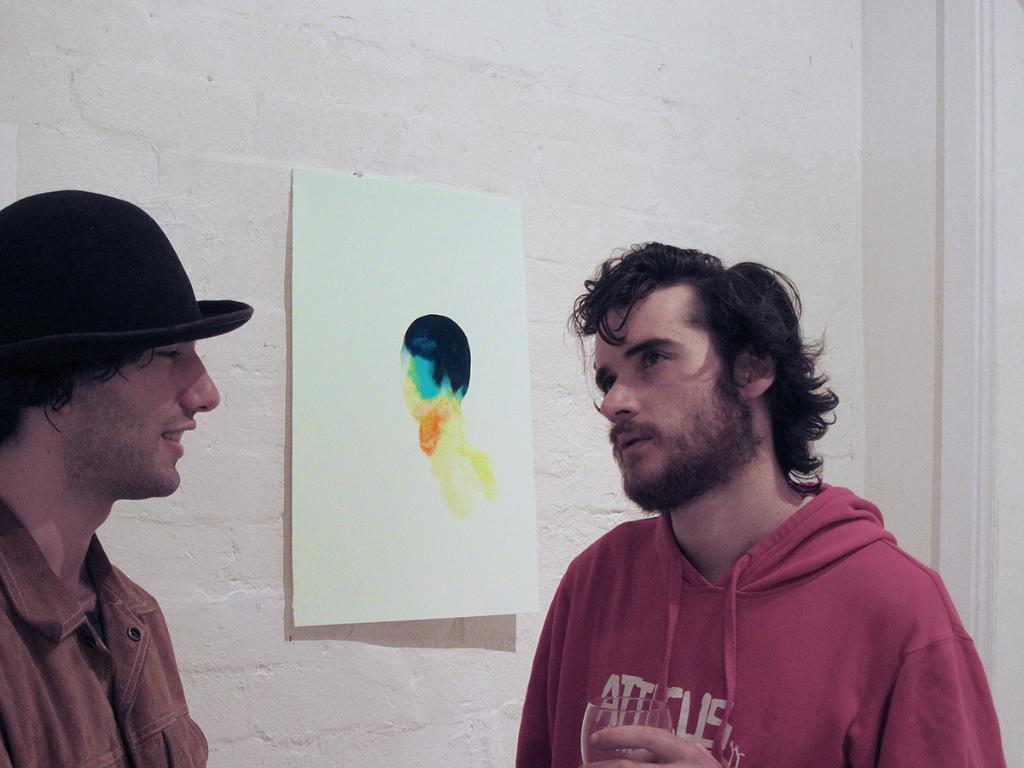Can you describe this image briefly? In this image I can see two people standing and facing each other. I can see a wall behind them with a wall painting. The person on the right hand side is holding a glass in his hand. 